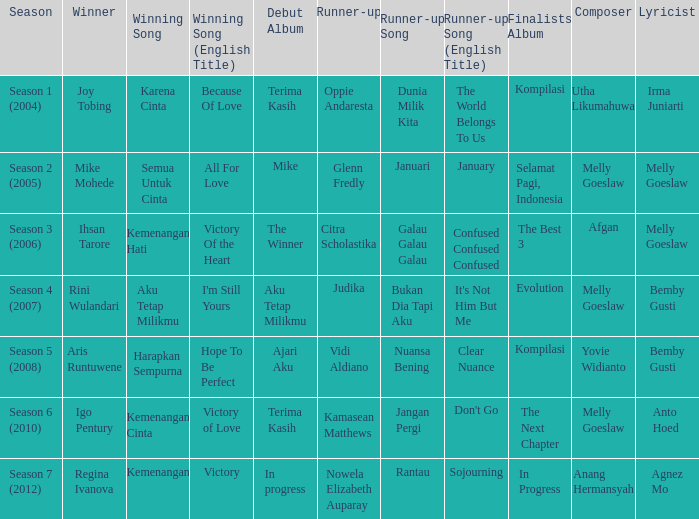Which winning song was sung by aku tetap milikmu? I'm Still Yours. Can you give me this table as a dict? {'header': ['Season', 'Winner', 'Winning Song', 'Winning Song (English Title)', 'Debut Album', 'Runner-up', 'Runner-up Song', 'Runner-up Song (English Title)', 'Finalists Album', 'Composer', 'Lyricist'], 'rows': [['Season 1 (2004)', 'Joy Tobing', 'Karena Cinta', 'Because Of Love', 'Terima Kasih', 'Oppie Andaresta', 'Dunia Milik Kita', 'The World Belongs To Us', 'Kompilasi', 'Utha Likumahuwa', 'Irma Juniarti '], ['Season 2 (2005)', 'Mike Mohede', 'Semua Untuk Cinta', 'All For Love', 'Mike', 'Glenn Fredly', 'Januari', 'January', 'Selamat Pagi, Indonesia', 'Melly Goeslaw', 'Melly Goeslaw '], ['Season 3 (2006)', 'Ihsan Tarore', 'Kemenangan Hati', 'Victory Of the Heart', 'The Winner', 'Citra Scholastika', 'Galau Galau Galau', 'Confused Confused Confused', 'The Best 3', 'Afgan', 'Melly Goeslaw '], ['Season 4 (2007)', 'Rini Wulandari', 'Aku Tetap Milikmu', "I'm Still Yours", 'Aku Tetap Milikmu', 'Judika', 'Bukan Dia Tapi Aku', "It's Not Him But Me", 'Evolution', 'Melly Goeslaw', 'Bemby Gusti '], ['Season 5 (2008)', 'Aris Runtuwene', 'Harapkan Sempurna', 'Hope To Be Perfect', 'Ajari Aku', 'Vidi Aldiano', 'Nuansa Bening', 'Clear Nuance', 'Kompilasi', 'Yovie Widianto', 'Bemby Gusti '], ['Season 6 (2010)', 'Igo Pentury', 'Kemenangan Cinta', 'Victory of Love', 'Terima Kasih', 'Kamasean Matthews', 'Jangan Pergi', "Don't Go", 'The Next Chapter', 'Melly Goeslaw', 'Anto Hoed '], ['Season 7 (2012)', 'Regina Ivanova', 'Kemenangan', 'Victory', 'In progress', 'Nowela Elizabeth Auparay', 'Rantau', 'Sojourning', 'In Progress', 'Anang Hermansyah', 'Agnez Mo']]} 